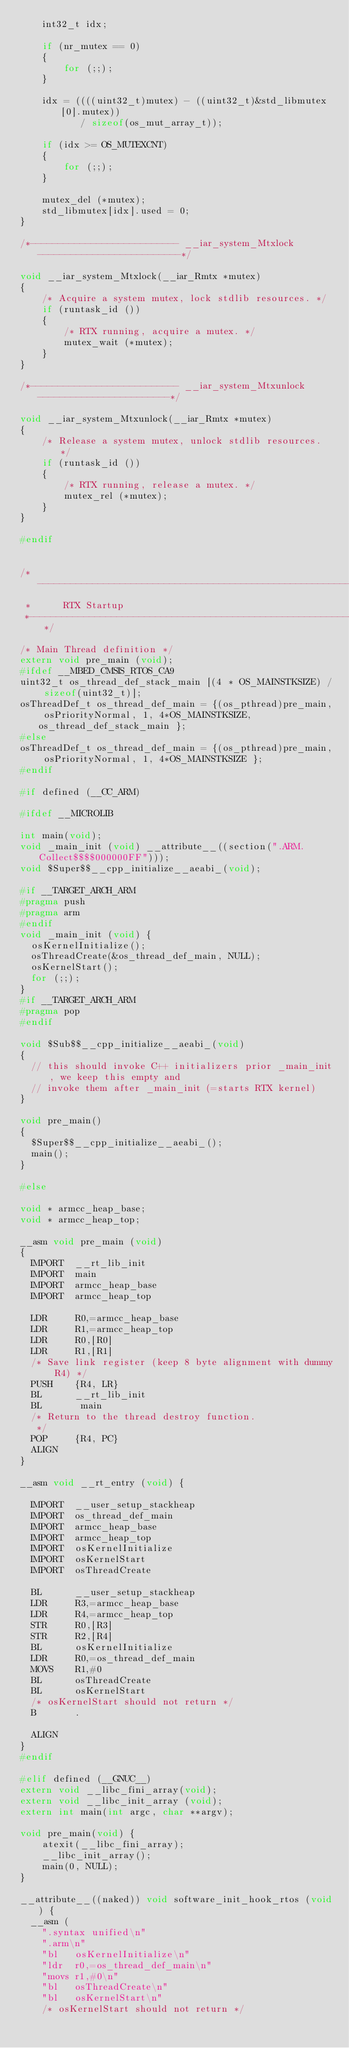Convert code to text. <code><loc_0><loc_0><loc_500><loc_500><_C_>    int32_t idx;

    if (nr_mutex == 0)
    {
        for (;;);
    }

    idx = ((((uint32_t)mutex) - ((uint32_t)&std_libmutex[0].mutex))
           / sizeof(os_mut_array_t));

    if (idx >= OS_MUTEXCNT)
    {
        for (;;);
    }

    mutex_del (*mutex);
    std_libmutex[idx].used = 0;
}

/*--------------------------- __iar_system_Mtxlock --------------------------*/

void __iar_system_Mtxlock(__iar_Rmtx *mutex)
{
    /* Acquire a system mutex, lock stdlib resources. */
    if (runtask_id ())
    {
        /* RTX running, acquire a mutex. */
        mutex_wait (*mutex);
    }
}

/*--------------------------- __iar_system_Mtxunlock ------------------------*/

void __iar_system_Mtxunlock(__iar_Rmtx *mutex)
{
    /* Release a system mutex, unlock stdlib resources. */
    if (runtask_id ())
    {
        /* RTX running, release a mutex. */
        mutex_rel (*mutex);
    }
}

#endif


/*----------------------------------------------------------------------------
 *      RTX Startup
 *---------------------------------------------------------------------------*/

/* Main Thread definition */
extern void pre_main (void);
#ifdef __MBED_CMSIS_RTOS_CA9
uint32_t os_thread_def_stack_main [(4 * OS_MAINSTKSIZE) / sizeof(uint32_t)];
osThreadDef_t os_thread_def_main = {(os_pthread)pre_main, osPriorityNormal, 1, 4*OS_MAINSTKSIZE, os_thread_def_stack_main };
#else
osThreadDef_t os_thread_def_main = {(os_pthread)pre_main, osPriorityNormal, 1, 4*OS_MAINSTKSIZE };
#endif

#if defined (__CC_ARM)

#ifdef __MICROLIB

int main(void);
void _main_init (void) __attribute__((section(".ARM.Collect$$$$000000FF")));
void $Super$$__cpp_initialize__aeabi_(void);

#if __TARGET_ARCH_ARM
#pragma push
#pragma arm
#endif
void _main_init (void) {
  osKernelInitialize();
  osThreadCreate(&os_thread_def_main, NULL);
  osKernelStart();
  for (;;);
}
#if __TARGET_ARCH_ARM
#pragma pop
#endif

void $Sub$$__cpp_initialize__aeabi_(void)  
{  
  // this should invoke C++ initializers prior _main_init, we keep this empty and  
  // invoke them after _main_init (=starts RTX kernel)  
}  

void pre_main()  
{  
  $Super$$__cpp_initialize__aeabi_();  
  main();  
}

#else

void * armcc_heap_base;
void * armcc_heap_top;

__asm void pre_main (void)
{
  IMPORT  __rt_lib_init
  IMPORT  main
  IMPORT  armcc_heap_base
  IMPORT  armcc_heap_top

  LDR     R0,=armcc_heap_base
  LDR     R1,=armcc_heap_top
  LDR     R0,[R0]
  LDR     R1,[R1]
  /* Save link register (keep 8 byte alignment with dummy R4) */
  PUSH    {R4, LR}
  BL      __rt_lib_init
  BL       main
  /* Return to the thread destroy function.
   */
  POP     {R4, PC}
  ALIGN
}

__asm void __rt_entry (void) {

  IMPORT  __user_setup_stackheap
  IMPORT  os_thread_def_main
  IMPORT  armcc_heap_base
  IMPORT  armcc_heap_top
  IMPORT  osKernelInitialize
  IMPORT  osKernelStart
  IMPORT  osThreadCreate

  BL      __user_setup_stackheap
  LDR     R3,=armcc_heap_base
  LDR     R4,=armcc_heap_top
  STR     R0,[R3]
  STR     R2,[R4]
  BL      osKernelInitialize
  LDR     R0,=os_thread_def_main
  MOVS    R1,#0
  BL      osThreadCreate
  BL      osKernelStart
  /* osKernelStart should not return */
  B       .

  ALIGN
}
#endif

#elif defined (__GNUC__)
extern void __libc_fini_array(void);
extern void __libc_init_array (void);
extern int main(int argc, char **argv);

void pre_main(void) {
    atexit(__libc_fini_array);
    __libc_init_array();
    main(0, NULL);
}

__attribute__((naked)) void software_init_hook_rtos (void) {
  __asm (
    ".syntax unified\n"
    ".arm\n"
    "bl   osKernelInitialize\n"
    "ldr  r0,=os_thread_def_main\n"
    "movs r1,#0\n"
    "bl   osThreadCreate\n"
    "bl   osKernelStart\n"
    /* osKernelStart should not return */ </code> 